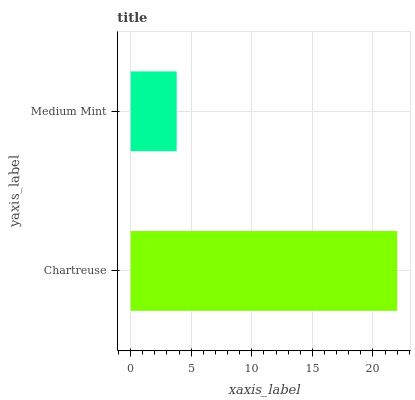Is Medium Mint the minimum?
Answer yes or no. Yes. Is Chartreuse the maximum?
Answer yes or no. Yes. Is Medium Mint the maximum?
Answer yes or no. No. Is Chartreuse greater than Medium Mint?
Answer yes or no. Yes. Is Medium Mint less than Chartreuse?
Answer yes or no. Yes. Is Medium Mint greater than Chartreuse?
Answer yes or no. No. Is Chartreuse less than Medium Mint?
Answer yes or no. No. Is Chartreuse the high median?
Answer yes or no. Yes. Is Medium Mint the low median?
Answer yes or no. Yes. Is Medium Mint the high median?
Answer yes or no. No. Is Chartreuse the low median?
Answer yes or no. No. 